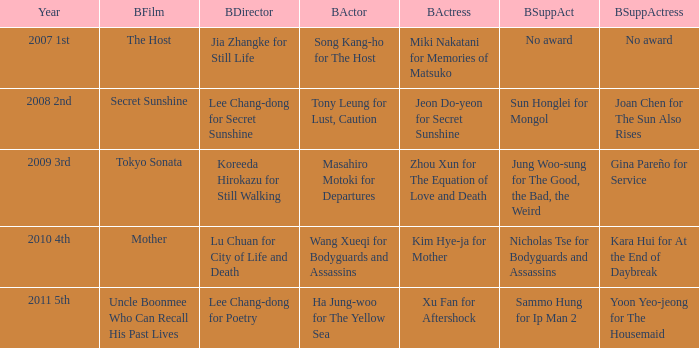Would you be able to parse every entry in this table? {'header': ['Year', 'BFilm', 'BDirector', 'BActor', 'BActress', 'BSuppAct', 'BSuppActress'], 'rows': [['2007 1st', 'The Host', 'Jia Zhangke for Still Life', 'Song Kang-ho for The Host', 'Miki Nakatani for Memories of Matsuko', 'No award', 'No award'], ['2008 2nd', 'Secret Sunshine', 'Lee Chang-dong for Secret Sunshine', 'Tony Leung for Lust, Caution', 'Jeon Do-yeon for Secret Sunshine', 'Sun Honglei for Mongol', 'Joan Chen for The Sun Also Rises'], ['2009 3rd', 'Tokyo Sonata', 'Koreeda Hirokazu for Still Walking', 'Masahiro Motoki for Departures', 'Zhou Xun for The Equation of Love and Death', 'Jung Woo-sung for The Good, the Bad, the Weird', 'Gina Pareño for Service'], ['2010 4th', 'Mother', 'Lu Chuan for City of Life and Death', 'Wang Xueqi for Bodyguards and Assassins', 'Kim Hye-ja for Mother', 'Nicholas Tse for Bodyguards and Assassins', 'Kara Hui for At the End of Daybreak'], ['2011 5th', 'Uncle Boonmee Who Can Recall His Past Lives', 'Lee Chang-dong for Poetry', 'Ha Jung-woo for The Yellow Sea', 'Xu Fan for Aftershock', 'Sammo Hung for Ip Man 2', 'Yoon Yeo-jeong for The Housemaid']]} Name the best supporting actress for sun honglei for mongol Joan Chen for The Sun Also Rises. 